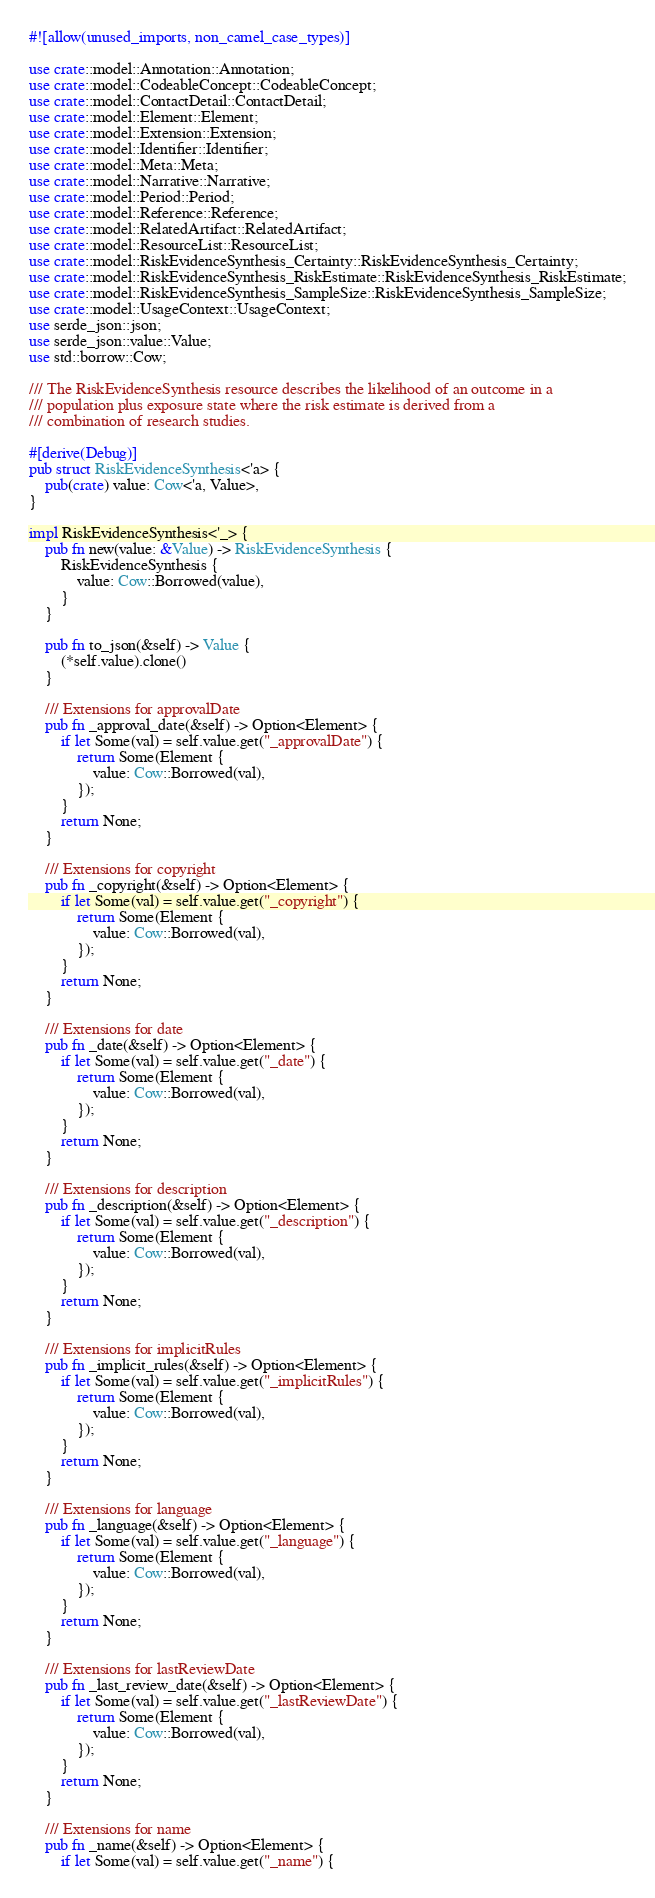Convert code to text. <code><loc_0><loc_0><loc_500><loc_500><_Rust_>#![allow(unused_imports, non_camel_case_types)]

use crate::model::Annotation::Annotation;
use crate::model::CodeableConcept::CodeableConcept;
use crate::model::ContactDetail::ContactDetail;
use crate::model::Element::Element;
use crate::model::Extension::Extension;
use crate::model::Identifier::Identifier;
use crate::model::Meta::Meta;
use crate::model::Narrative::Narrative;
use crate::model::Period::Period;
use crate::model::Reference::Reference;
use crate::model::RelatedArtifact::RelatedArtifact;
use crate::model::ResourceList::ResourceList;
use crate::model::RiskEvidenceSynthesis_Certainty::RiskEvidenceSynthesis_Certainty;
use crate::model::RiskEvidenceSynthesis_RiskEstimate::RiskEvidenceSynthesis_RiskEstimate;
use crate::model::RiskEvidenceSynthesis_SampleSize::RiskEvidenceSynthesis_SampleSize;
use crate::model::UsageContext::UsageContext;
use serde_json::json;
use serde_json::value::Value;
use std::borrow::Cow;

/// The RiskEvidenceSynthesis resource describes the likelihood of an outcome in a
/// population plus exposure state where the risk estimate is derived from a
/// combination of research studies.

#[derive(Debug)]
pub struct RiskEvidenceSynthesis<'a> {
    pub(crate) value: Cow<'a, Value>,
}

impl RiskEvidenceSynthesis<'_> {
    pub fn new(value: &Value) -> RiskEvidenceSynthesis {
        RiskEvidenceSynthesis {
            value: Cow::Borrowed(value),
        }
    }

    pub fn to_json(&self) -> Value {
        (*self.value).clone()
    }

    /// Extensions for approvalDate
    pub fn _approval_date(&self) -> Option<Element> {
        if let Some(val) = self.value.get("_approvalDate") {
            return Some(Element {
                value: Cow::Borrowed(val),
            });
        }
        return None;
    }

    /// Extensions for copyright
    pub fn _copyright(&self) -> Option<Element> {
        if let Some(val) = self.value.get("_copyright") {
            return Some(Element {
                value: Cow::Borrowed(val),
            });
        }
        return None;
    }

    /// Extensions for date
    pub fn _date(&self) -> Option<Element> {
        if let Some(val) = self.value.get("_date") {
            return Some(Element {
                value: Cow::Borrowed(val),
            });
        }
        return None;
    }

    /// Extensions for description
    pub fn _description(&self) -> Option<Element> {
        if let Some(val) = self.value.get("_description") {
            return Some(Element {
                value: Cow::Borrowed(val),
            });
        }
        return None;
    }

    /// Extensions for implicitRules
    pub fn _implicit_rules(&self) -> Option<Element> {
        if let Some(val) = self.value.get("_implicitRules") {
            return Some(Element {
                value: Cow::Borrowed(val),
            });
        }
        return None;
    }

    /// Extensions for language
    pub fn _language(&self) -> Option<Element> {
        if let Some(val) = self.value.get("_language") {
            return Some(Element {
                value: Cow::Borrowed(val),
            });
        }
        return None;
    }

    /// Extensions for lastReviewDate
    pub fn _last_review_date(&self) -> Option<Element> {
        if let Some(val) = self.value.get("_lastReviewDate") {
            return Some(Element {
                value: Cow::Borrowed(val),
            });
        }
        return None;
    }

    /// Extensions for name
    pub fn _name(&self) -> Option<Element> {
        if let Some(val) = self.value.get("_name") {</code> 